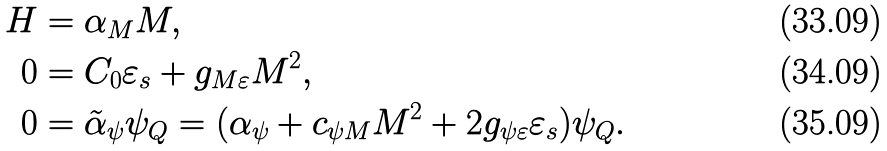Convert formula to latex. <formula><loc_0><loc_0><loc_500><loc_500>H & = \alpha _ { M } M , \\ 0 & = C _ { 0 } \varepsilon _ { s } + g _ { M \varepsilon } M ^ { 2 } , \\ 0 & = \tilde { \alpha } _ { \psi } \psi _ { Q } = ( \alpha _ { \psi } + c _ { \psi M } M ^ { 2 } + 2 g _ { \psi \varepsilon } \varepsilon _ { s } ) \psi _ { Q } .</formula> 